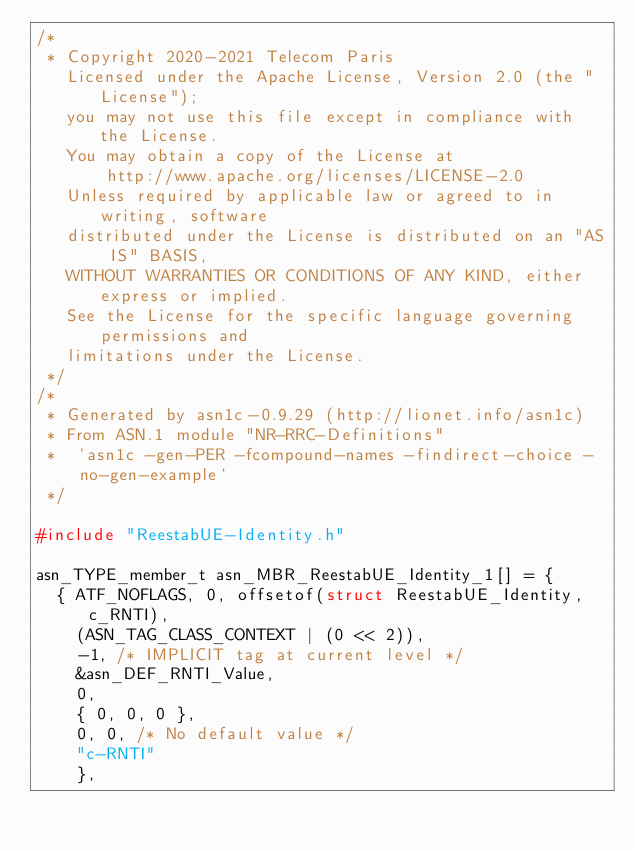<code> <loc_0><loc_0><loc_500><loc_500><_C_>/*
 * Copyright 2020-2021 Telecom Paris
   Licensed under the Apache License, Version 2.0 (the "License");
   you may not use this file except in compliance with the License.
   You may obtain a copy of the License at
       http://www.apache.org/licenses/LICENSE-2.0
   Unless required by applicable law or agreed to in writing, software
   distributed under the License is distributed on an "AS IS" BASIS,
   WITHOUT WARRANTIES OR CONDITIONS OF ANY KIND, either express or implied.
   See the License for the specific language governing permissions and
   limitations under the License.
 */
/*
 * Generated by asn1c-0.9.29 (http://lionet.info/asn1c)
 * From ASN.1 module "NR-RRC-Definitions"
 * 	`asn1c -gen-PER -fcompound-names -findirect-choice -no-gen-example`
 */

#include "ReestabUE-Identity.h"

asn_TYPE_member_t asn_MBR_ReestabUE_Identity_1[] = {
	{ ATF_NOFLAGS, 0, offsetof(struct ReestabUE_Identity, c_RNTI),
		(ASN_TAG_CLASS_CONTEXT | (0 << 2)),
		-1,	/* IMPLICIT tag at current level */
		&asn_DEF_RNTI_Value,
		0,
		{ 0, 0, 0 },
		0, 0, /* No default value */
		"c-RNTI"
		},</code> 